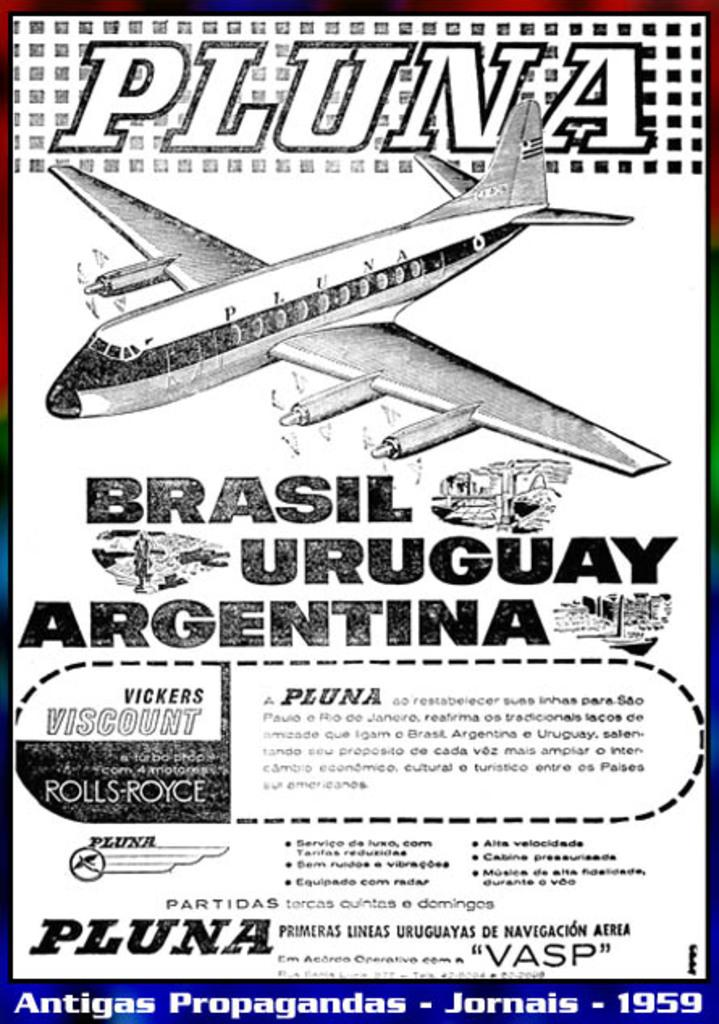Provide a one-sentence caption for the provided image. An ad for Pluna which travels to Brasil, Uruguay and Argentina. 